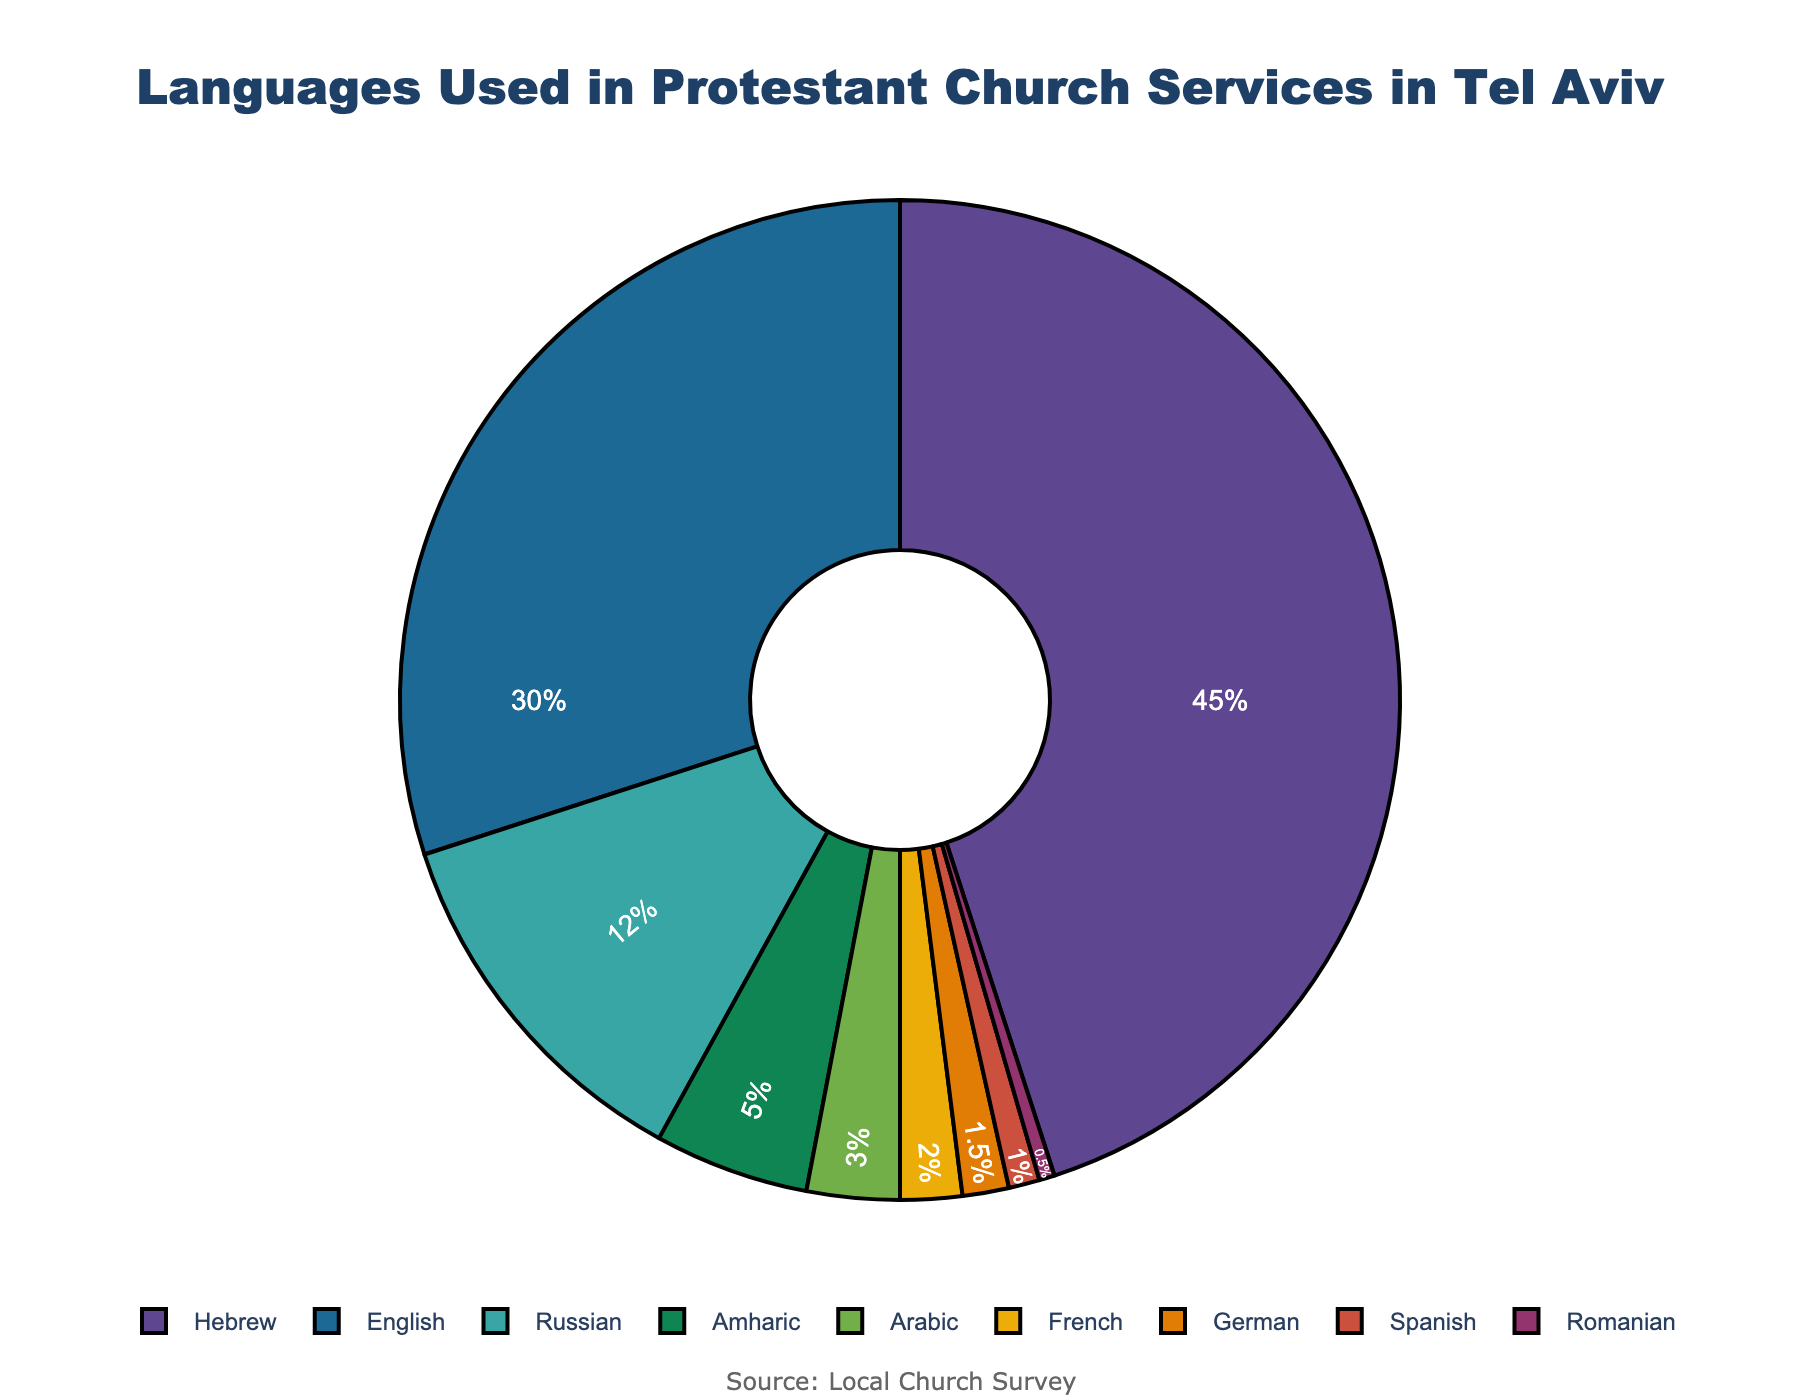What's the most common language used in Protestant church services in Tel Aviv? The figure shows different languages and their percentages. The highest percentage is for Hebrew at 45%.
Answer: Hebrew What's the total percentage of services conducted in Russian and Amharic? Sum the percentages of Russian (12%) and Amharic (5%) services. 12 + 5 = 17.
Answer: 17% Which language has the least representation in church services? The language with the smallest percentage is Romanian at 0.5%.
Answer: Romanian How many languages are used for at least 10% of the services? Languages used for at least 10% of the services are Hebrew (45%), English (30%), and Russian (12%). Count them.
Answer: 3 Is English used more frequently than Russian and Amharic combined? Compare English (30%) with the sum of Russian and Amharic (12% + 5% = 17%). 30% is greater than 17%.
Answer: Yes What percentage of services are conducted in languages other than Hebrew, English, and Russian? Subtract the percentages of Hebrew, English, and Russian from 100%. 100 - 45 - 30 - 12 = 13.
Answer: 13% Do French and German together account for more or less than 5% of the services? Sum the percentages of French (2%) and German (1.5%). 2 + 1.5 = 3.5. 3.5% is less than 5%.
Answer: Less Which language is represented by the smallest slice in the chart? The smallest slice corresponds to the smallest percentage, which is Romanian at 0.5%.
Answer: Romanian What is the combined percentage of languages used for less than 5% of the services? Sum the percentages of Amharic (5%), Arabic (3%), French (2%), German (1.5%), Spanish (1%), and Romanian (0.5%) that are all less than 5%. 5 + 3 + 2 + 1.5 + 1 + 0.5 = 13.
Answer: 13% Is the gap between the percentage of Hebrew and English services bigger than the gap between English and Russian services? Calculate the gap between Hebrew (45%) and English (30%), which is 45 - 30 = 15. The gap between English (30%) and Russian (12%) is 30 - 12 = 18. 15 is less than 18.
Answer: No 